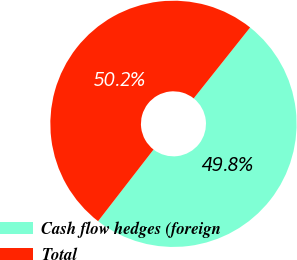Convert chart. <chart><loc_0><loc_0><loc_500><loc_500><pie_chart><fcel>Cash flow hedges (foreign<fcel>Total<nl><fcel>49.79%<fcel>50.21%<nl></chart> 